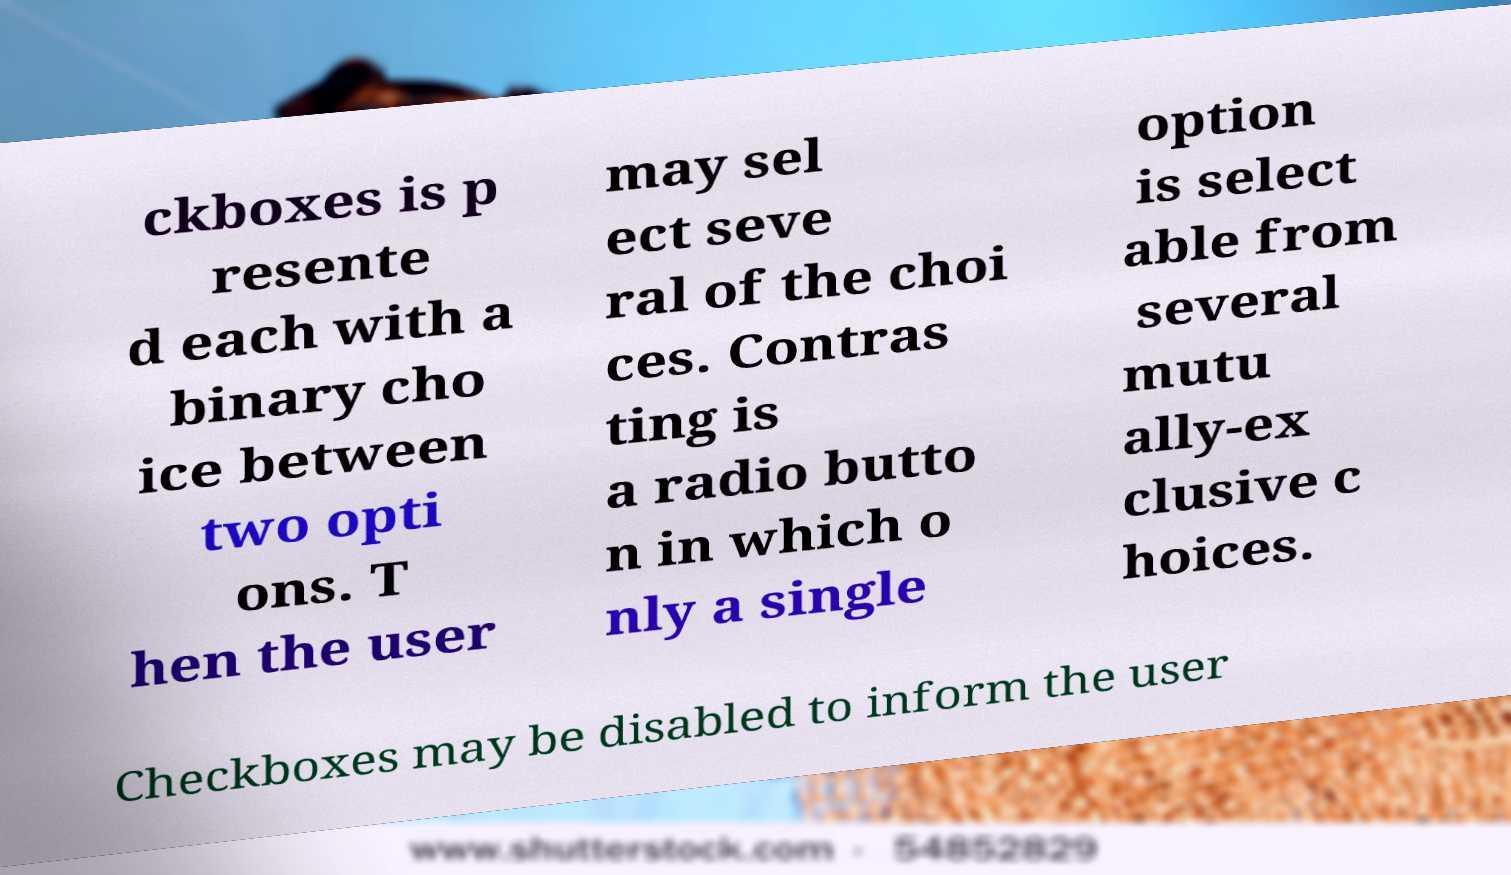What messages or text are displayed in this image? I need them in a readable, typed format. ckboxes is p resente d each with a binary cho ice between two opti ons. T hen the user may sel ect seve ral of the choi ces. Contras ting is a radio butto n in which o nly a single option is select able from several mutu ally-ex clusive c hoices. Checkboxes may be disabled to inform the user 